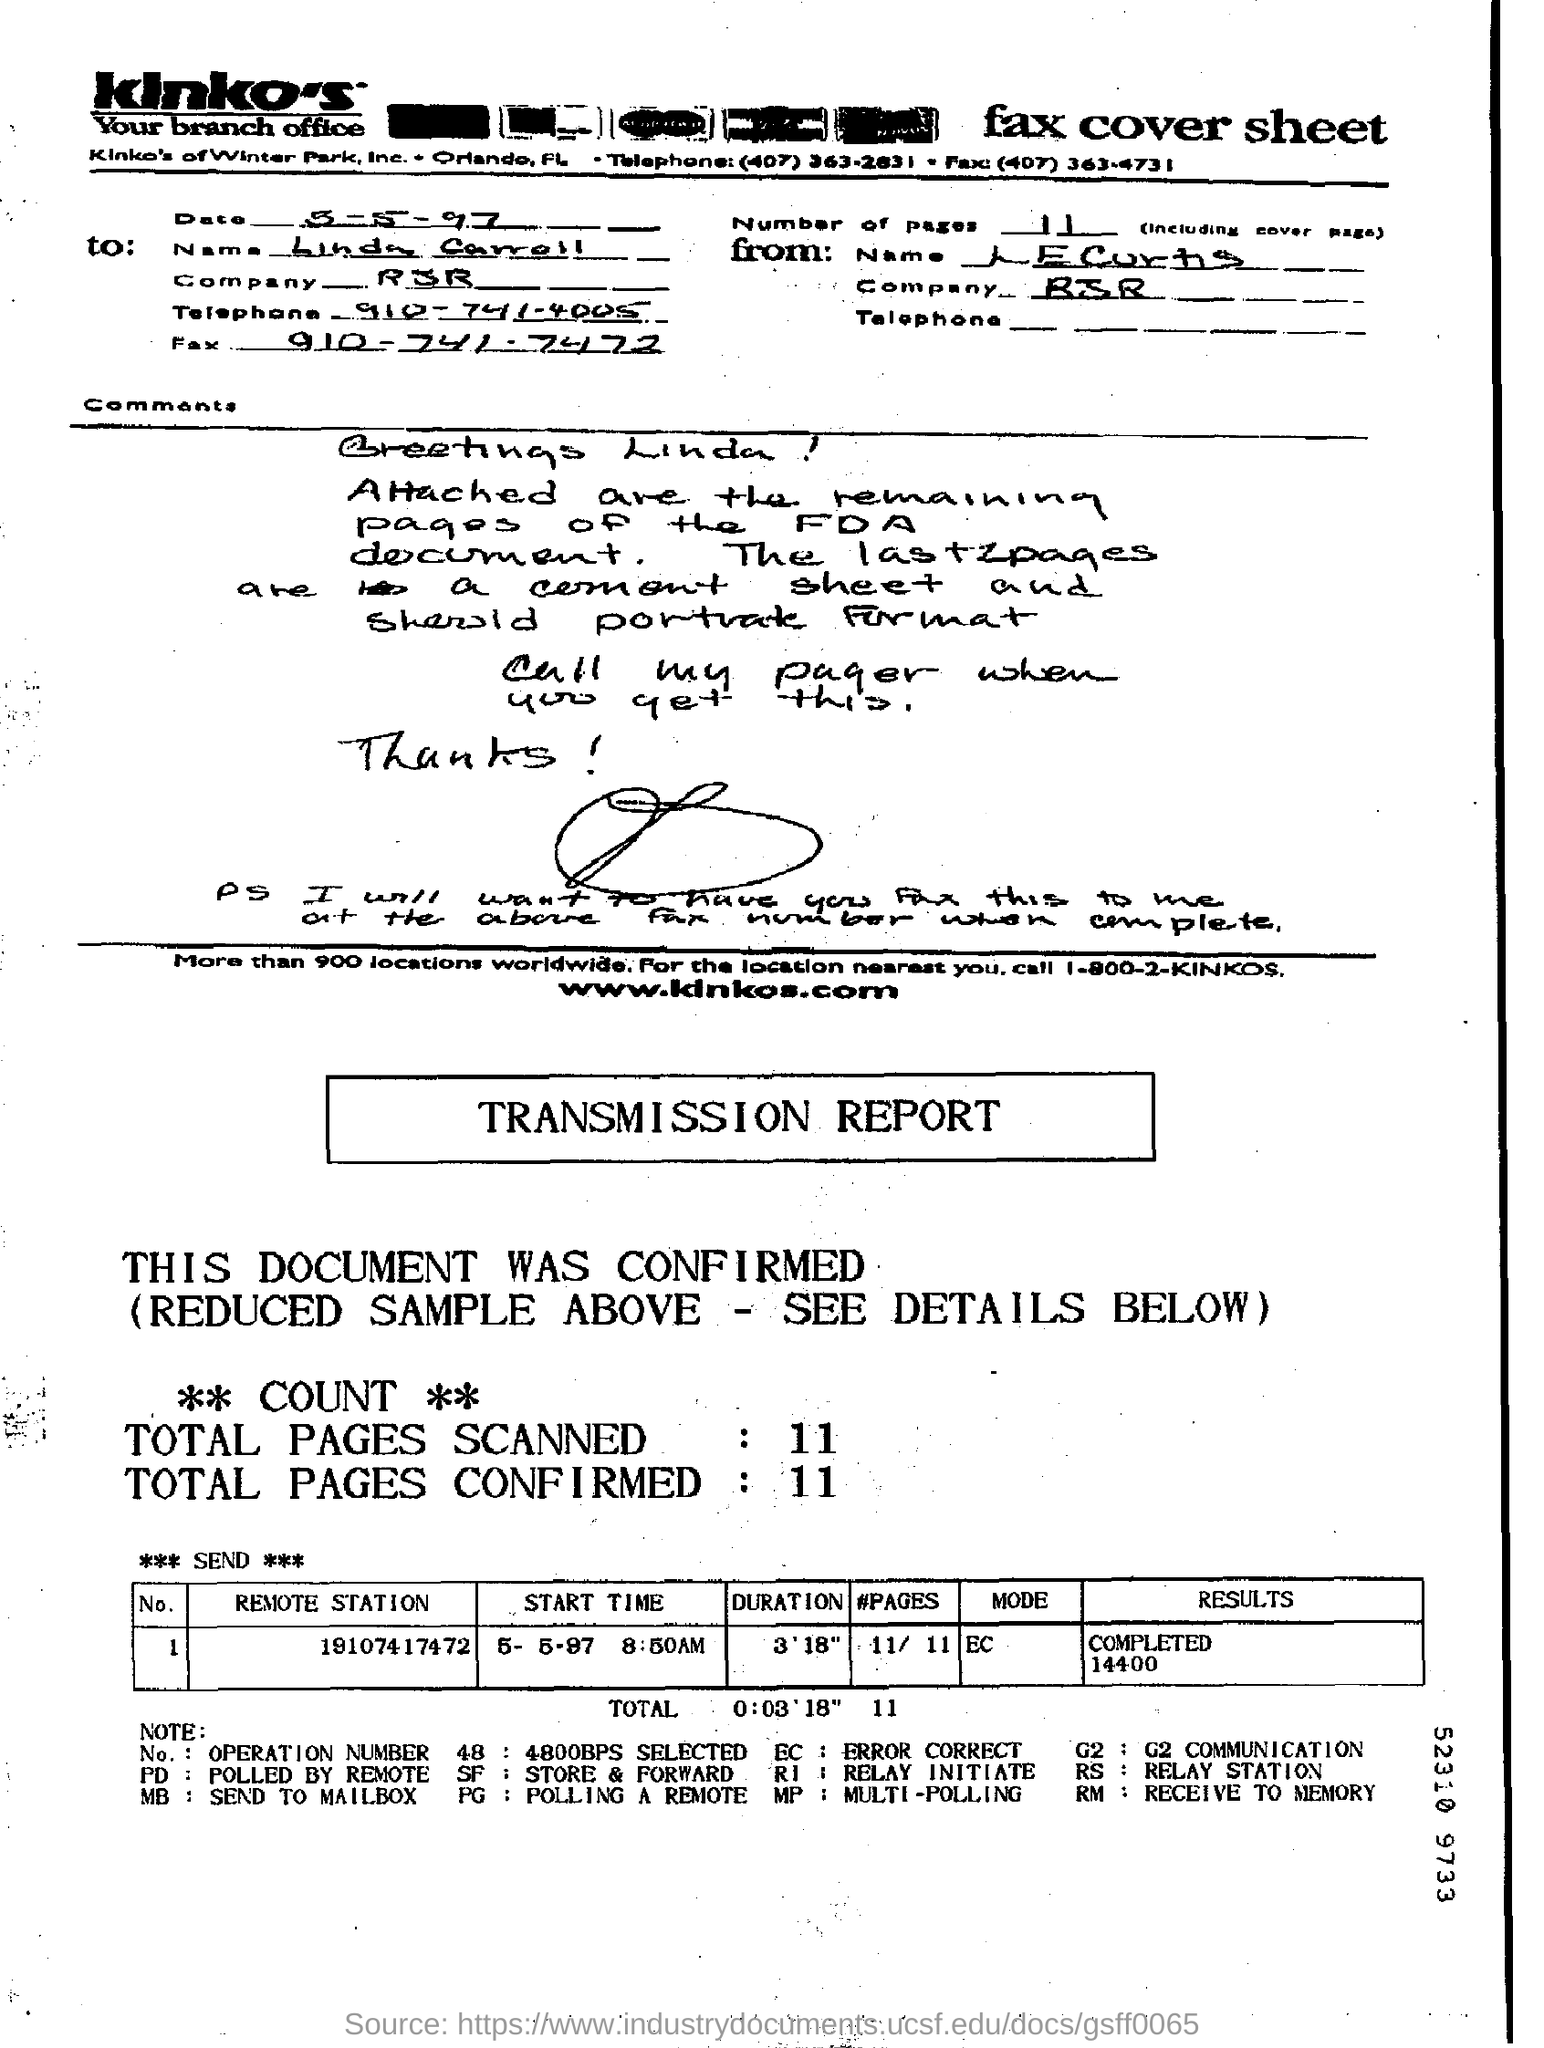List a handful of essential elements in this visual. The date is May 5th, 1997. The "Results" for the "Remote station" with the identifier "19107417472" have been completed after 14400 seconds. The fax is addressed to Linda Carroll. The total number of pages scanned is 11. The duration for the remote station 19107417472 is 3 minutes and 18 seconds. 